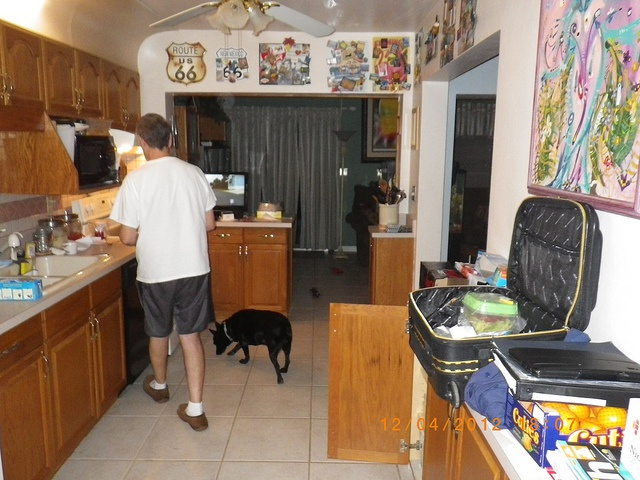Describe the objects in this image and their specific colors. I can see people in white, lightgray, black, and gray tones, suitcase in white, gray, black, darkgray, and khaki tones, dog in white, black, gray, and maroon tones, laptop in white, black, and gray tones, and sink in white, darkgray, tan, and gray tones in this image. 